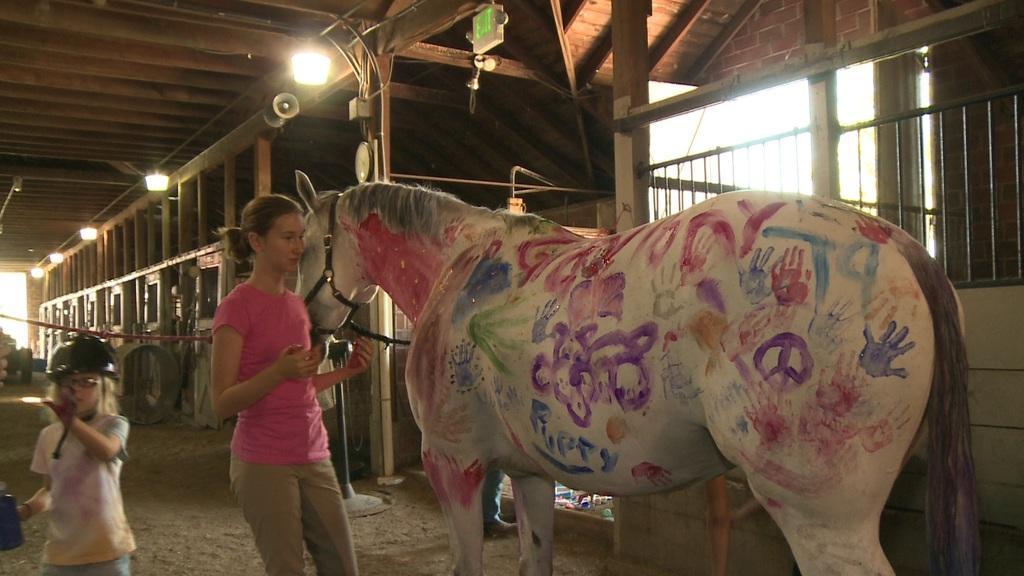Could you give a brief overview of what you see in this image? This picture shows a stable and we see a woman,a horse and a girl standing and we see few lights 